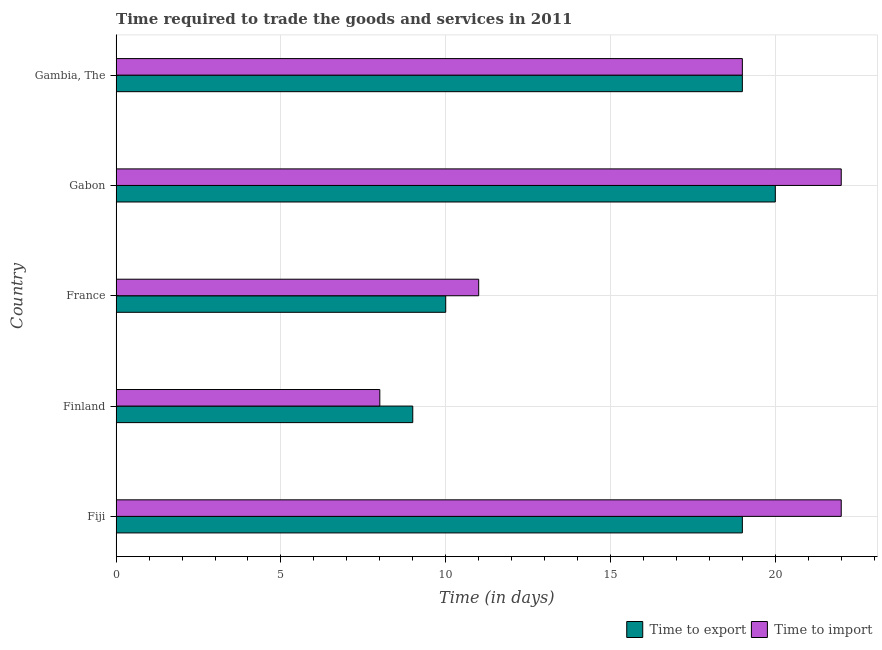How many different coloured bars are there?
Keep it short and to the point. 2. What is the label of the 2nd group of bars from the top?
Provide a succinct answer. Gabon. In how many cases, is the number of bars for a given country not equal to the number of legend labels?
Offer a terse response. 0. What is the time to import in Gambia, The?
Offer a terse response. 19. Across all countries, what is the maximum time to export?
Give a very brief answer. 20. Across all countries, what is the minimum time to import?
Your answer should be very brief. 8. In which country was the time to import maximum?
Provide a succinct answer. Fiji. What is the total time to import in the graph?
Provide a short and direct response. 82. What is the difference between the time to export in Fiji and that in France?
Give a very brief answer. 9. What is the difference between the time to export in Gambia, The and the time to import in Gabon?
Make the answer very short. -3. What is the difference between the time to import and time to export in Gabon?
Keep it short and to the point. 2. In how many countries, is the time to export greater than 9 days?
Give a very brief answer. 4. What is the ratio of the time to export in Finland to that in Gambia, The?
Your answer should be very brief. 0.47. Is the difference between the time to import in Finland and Gabon greater than the difference between the time to export in Finland and Gabon?
Your response must be concise. No. What is the difference between the highest and the second highest time to export?
Ensure brevity in your answer.  1. What is the difference between the highest and the lowest time to import?
Provide a succinct answer. 14. In how many countries, is the time to export greater than the average time to export taken over all countries?
Provide a succinct answer. 3. Is the sum of the time to export in France and Gambia, The greater than the maximum time to import across all countries?
Provide a succinct answer. Yes. What does the 2nd bar from the top in France represents?
Give a very brief answer. Time to export. What does the 2nd bar from the bottom in Gambia, The represents?
Your answer should be compact. Time to import. Are all the bars in the graph horizontal?
Offer a terse response. Yes. How many countries are there in the graph?
Ensure brevity in your answer.  5. What is the difference between two consecutive major ticks on the X-axis?
Your answer should be very brief. 5. Are the values on the major ticks of X-axis written in scientific E-notation?
Make the answer very short. No. How many legend labels are there?
Your answer should be very brief. 2. How are the legend labels stacked?
Make the answer very short. Horizontal. What is the title of the graph?
Provide a succinct answer. Time required to trade the goods and services in 2011. What is the label or title of the X-axis?
Your answer should be very brief. Time (in days). What is the label or title of the Y-axis?
Offer a terse response. Country. What is the Time (in days) in Time to import in Fiji?
Keep it short and to the point. 22. What is the Time (in days) of Time to export in Finland?
Your answer should be very brief. 9. What is the Time (in days) of Time to export in France?
Your response must be concise. 10. What is the Time (in days) in Time to import in France?
Give a very brief answer. 11. Across all countries, what is the minimum Time (in days) in Time to export?
Offer a terse response. 9. What is the difference between the Time (in days) of Time to export in Fiji and that in Finland?
Keep it short and to the point. 10. What is the difference between the Time (in days) of Time to import in Fiji and that in France?
Keep it short and to the point. 11. What is the difference between the Time (in days) of Time to export in Fiji and that in Gabon?
Make the answer very short. -1. What is the difference between the Time (in days) of Time to export in Fiji and that in Gambia, The?
Give a very brief answer. 0. What is the difference between the Time (in days) of Time to export in Finland and that in France?
Offer a very short reply. -1. What is the difference between the Time (in days) in Time to export in Finland and that in Gambia, The?
Your response must be concise. -10. What is the difference between the Time (in days) of Time to import in Finland and that in Gambia, The?
Your answer should be compact. -11. What is the difference between the Time (in days) in Time to export in France and that in Gabon?
Your answer should be very brief. -10. What is the difference between the Time (in days) of Time to import in France and that in Gabon?
Keep it short and to the point. -11. What is the difference between the Time (in days) of Time to export in France and that in Gambia, The?
Ensure brevity in your answer.  -9. What is the difference between the Time (in days) of Time to import in Gabon and that in Gambia, The?
Offer a terse response. 3. What is the difference between the Time (in days) of Time to export in Fiji and the Time (in days) of Time to import in Finland?
Keep it short and to the point. 11. What is the difference between the Time (in days) of Time to export in Fiji and the Time (in days) of Time to import in France?
Your answer should be very brief. 8. What is the difference between the Time (in days) in Time to export in Fiji and the Time (in days) in Time to import in Gabon?
Your response must be concise. -3. What is the difference between the Time (in days) in Time to export in France and the Time (in days) in Time to import in Gabon?
Provide a short and direct response. -12. What is the average Time (in days) in Time to export per country?
Your answer should be compact. 15.4. What is the average Time (in days) of Time to import per country?
Give a very brief answer. 16.4. What is the difference between the Time (in days) in Time to export and Time (in days) in Time to import in Finland?
Your answer should be compact. 1. What is the difference between the Time (in days) in Time to export and Time (in days) in Time to import in Gabon?
Your response must be concise. -2. What is the ratio of the Time (in days) in Time to export in Fiji to that in Finland?
Provide a succinct answer. 2.11. What is the ratio of the Time (in days) of Time to import in Fiji to that in Finland?
Ensure brevity in your answer.  2.75. What is the ratio of the Time (in days) in Time to export in Fiji to that in France?
Your answer should be very brief. 1.9. What is the ratio of the Time (in days) of Time to import in Fiji to that in France?
Provide a short and direct response. 2. What is the ratio of the Time (in days) of Time to export in Fiji to that in Gabon?
Offer a terse response. 0.95. What is the ratio of the Time (in days) of Time to import in Fiji to that in Gambia, The?
Offer a terse response. 1.16. What is the ratio of the Time (in days) of Time to import in Finland to that in France?
Your response must be concise. 0.73. What is the ratio of the Time (in days) in Time to export in Finland to that in Gabon?
Keep it short and to the point. 0.45. What is the ratio of the Time (in days) in Time to import in Finland to that in Gabon?
Your answer should be very brief. 0.36. What is the ratio of the Time (in days) in Time to export in Finland to that in Gambia, The?
Your response must be concise. 0.47. What is the ratio of the Time (in days) in Time to import in Finland to that in Gambia, The?
Offer a very short reply. 0.42. What is the ratio of the Time (in days) in Time to export in France to that in Gabon?
Keep it short and to the point. 0.5. What is the ratio of the Time (in days) in Time to export in France to that in Gambia, The?
Your answer should be compact. 0.53. What is the ratio of the Time (in days) in Time to import in France to that in Gambia, The?
Your answer should be compact. 0.58. What is the ratio of the Time (in days) of Time to export in Gabon to that in Gambia, The?
Give a very brief answer. 1.05. What is the ratio of the Time (in days) of Time to import in Gabon to that in Gambia, The?
Make the answer very short. 1.16. What is the difference between the highest and the second highest Time (in days) in Time to import?
Offer a very short reply. 0. What is the difference between the highest and the lowest Time (in days) in Time to export?
Make the answer very short. 11. What is the difference between the highest and the lowest Time (in days) in Time to import?
Offer a terse response. 14. 